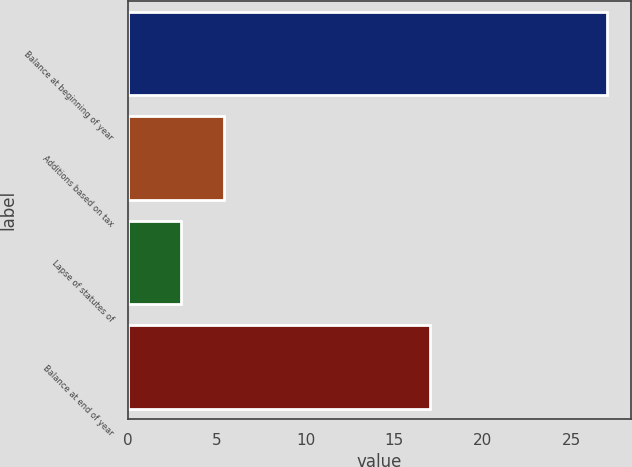Convert chart. <chart><loc_0><loc_0><loc_500><loc_500><bar_chart><fcel>Balance at beginning of year<fcel>Additions based on tax<fcel>Lapse of statutes of<fcel>Balance at end of year<nl><fcel>27<fcel>5.4<fcel>3<fcel>17<nl></chart> 